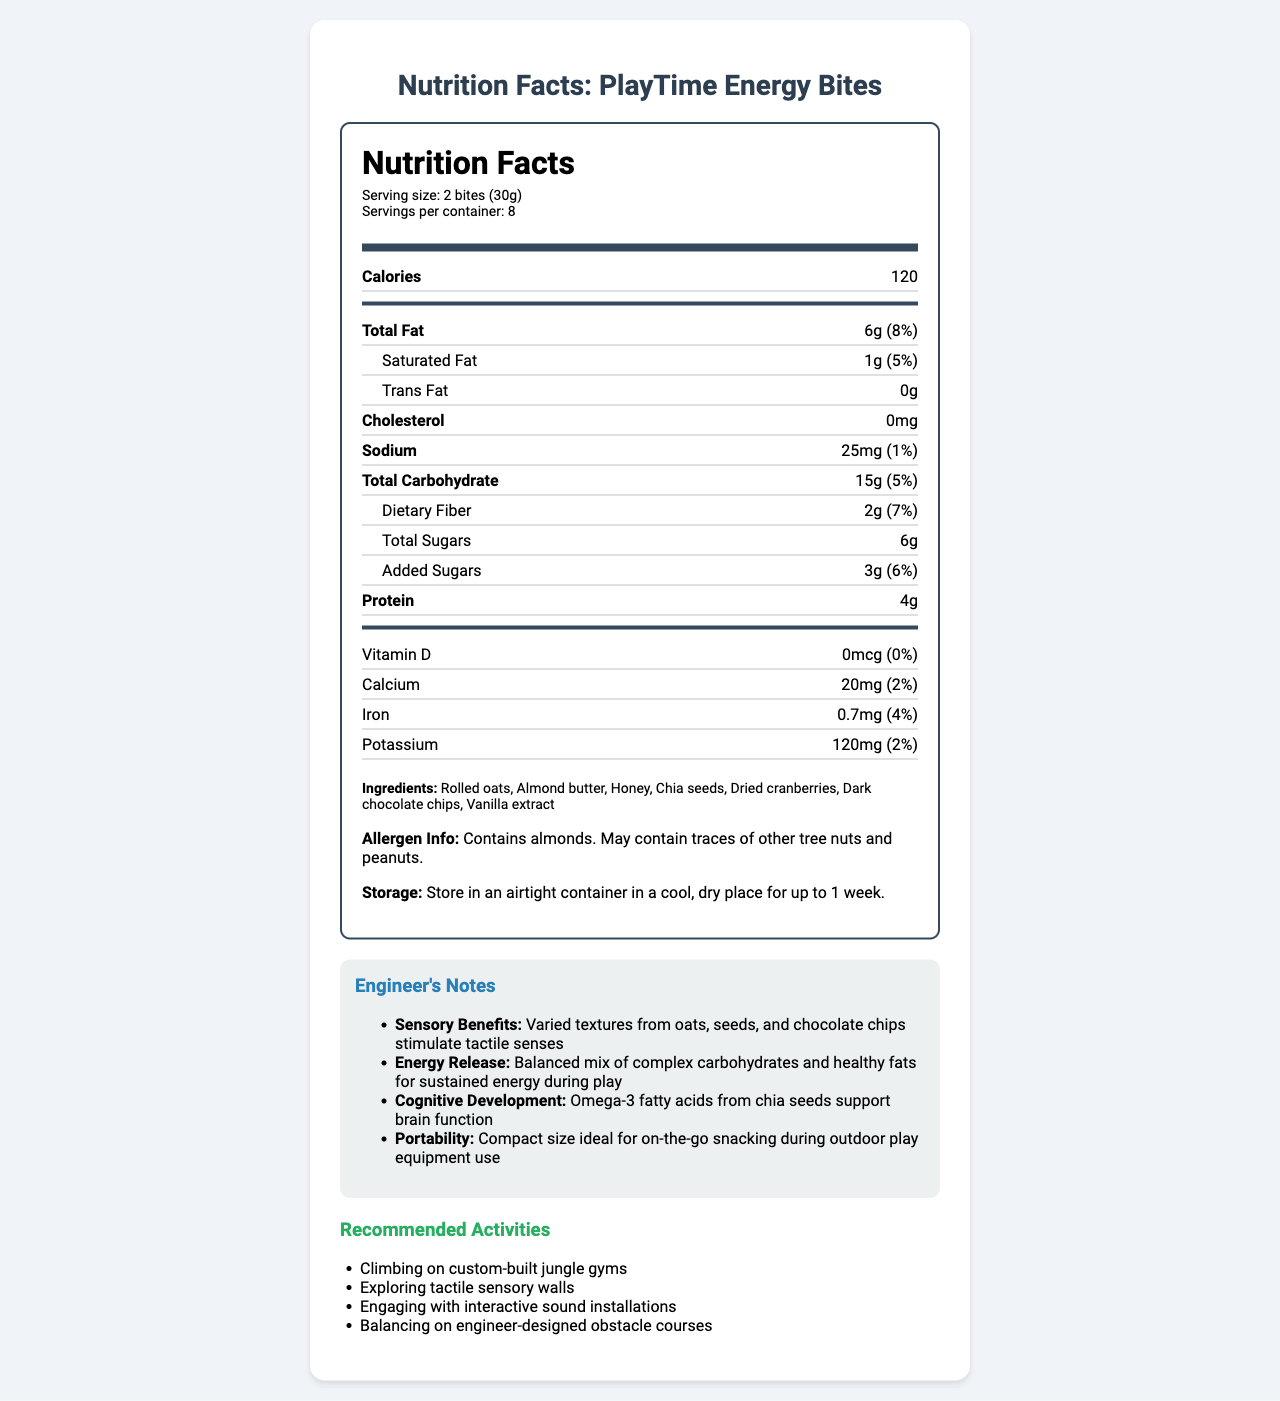what is the serving size? The serving size is listed as "2 bites (30g)" in the "Nutrition Facts" section of the document.
Answer: 2 bites (30g) how many calories are there per serving? The number of calories per serving is shown as "120" in the top section of the nutritional information.
Answer: 120 what is the amount of total fat in one serving? The total fat amount is listed as "6g".
Answer: 6g what percentage of the daily value is the saturated fat? The percentage of the daily value for saturated fat is given as "5%" next to the amount.
Answer: 5% what is the protein content per serving? The protein content per serving is indicated as "4g" in the nutritional information.
Answer: 4g which ingredient is not a nut? A. Rolled oats B. Almond butter C. Dark chocolate chips Rolled oats are grains, while almonds are nuts.
Answer: A how much dietary fiber is in each serving? The dietary fiber content per serving is shown as "2g" in the nutritional information section.
Answer: 2g what allergen is specifically mentioned in the allergen info? The allergen info states that the product contains almonds.
Answer: Almonds how should the product be stored? The storage instructions specify to keep the product in an airtight container in a cool, dry place for up to 1 week.
Answer: In an airtight container in a cool, dry place for up to 1 week true or false: this product contains added sugars. The document lists "3g" of added sugars in the nutritional information.
Answer: True how does this product benefit cognitive development? The engineer's notes explain that omega-3 fatty acids from chia seeds benefit cognitive development by supporting brain function.
Answer: Omega-3 fatty acids from chia seeds support brain function what are the recommended activities while consuming this snack? The recommended activities are listed under "Recommended Activities."
Answer: Climbing on custom-built jungle gyms, Exploring tactile sensory walls, Engaging with interactive sound installations, Balancing on engineer-designed obstacle courses what is the potassium content per serving? The potassium content per serving is stated as "120mg."
Answer: 120mg which vitamin is not present in the product? A. Vitamin D B. Calcium C. Iron D. Potassium The vitamin D amount is listed as "0mcg" with a daily value of "0%."
Answer: A describe the overall purpose of this document. The overall purpose is to give detailed nutritional and additional information about the product to ensure it supports children's energy and development during play.
Answer: The document provides comprehensive nutritional information, storage instructions, allergen details, and benefits of "PlayTime Energy Bites," a healthy snack aimed at energizing children during play. It also includes specific sensory, cognitive, and portability notes, as well as recommended activities for children to engage with while consuming the snack. what is the manufacturing date of the product? The document does not provide any information about the manufacturing date of the product.
Answer: Not enough information 